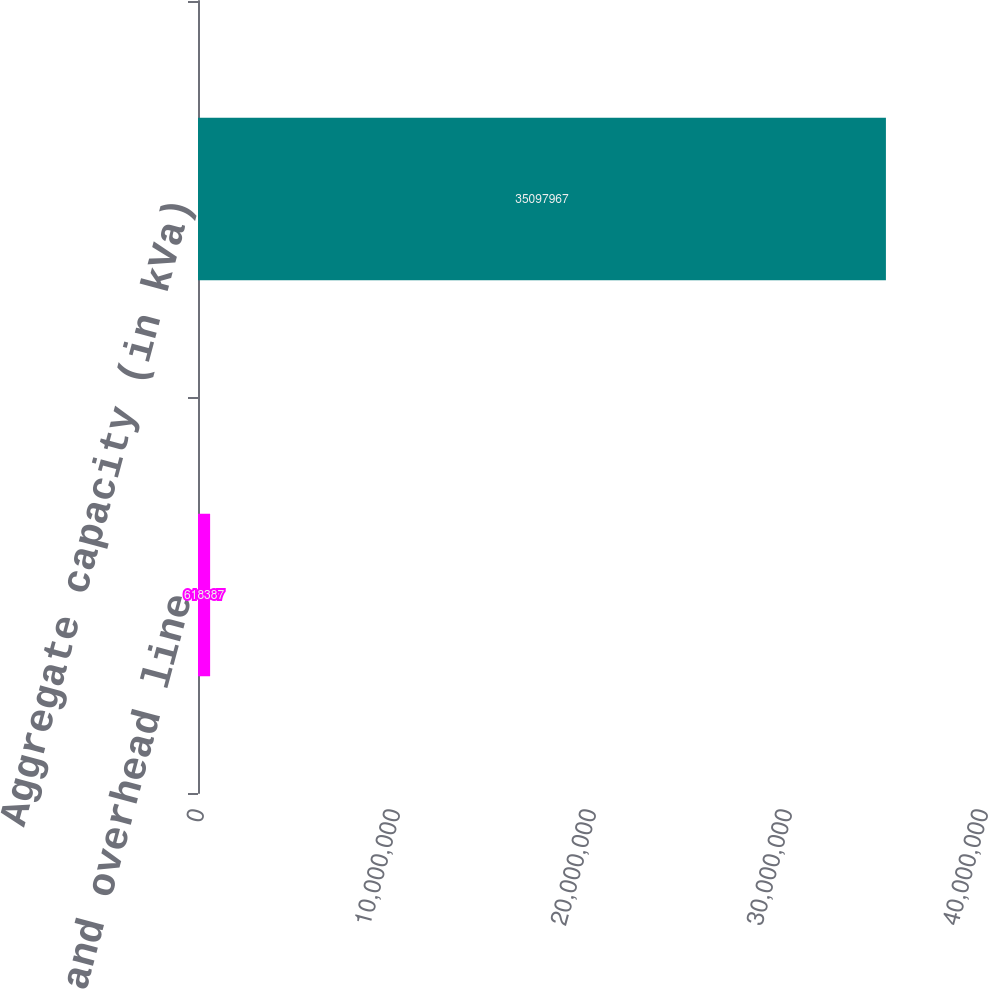Convert chart. <chart><loc_0><loc_0><loc_500><loc_500><bar_chart><fcel>Underground and overhead line<fcel>Aggregate capacity (in kVa)<nl><fcel>618387<fcel>3.5098e+07<nl></chart> 